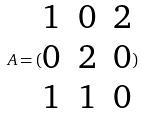Convert formula to latex. <formula><loc_0><loc_0><loc_500><loc_500>A = ( \begin{matrix} 1 & 0 & 2 \\ 0 & 2 & 0 \\ 1 & 1 & 0 \end{matrix} )</formula> 